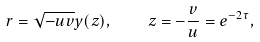<formula> <loc_0><loc_0><loc_500><loc_500>r = \sqrt { - u v } y ( z ) , \quad z = - \frac { v } { u } = e ^ { - 2 \tau } ,</formula> 